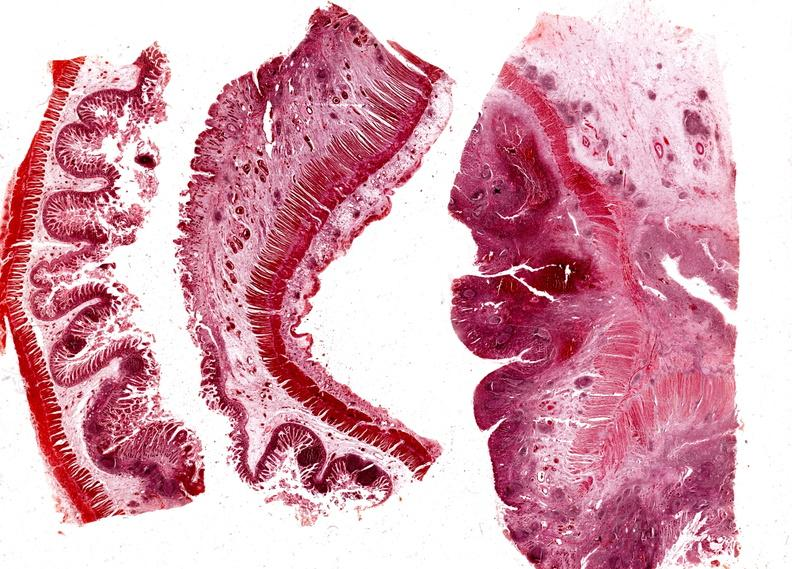does sickle cell disease show colon, regional enteritis?
Answer the question using a single word or phrase. No 